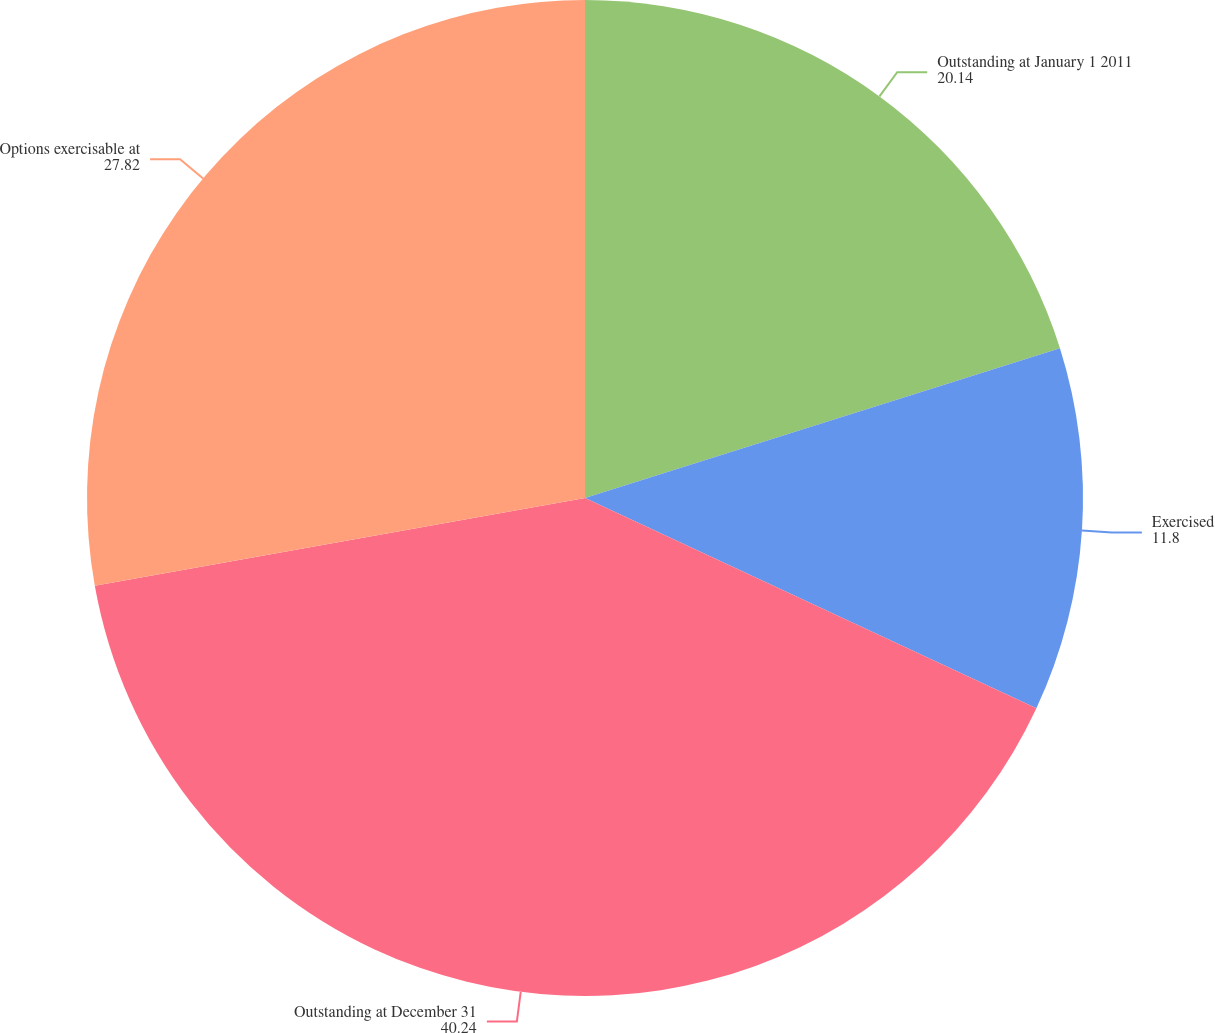Convert chart. <chart><loc_0><loc_0><loc_500><loc_500><pie_chart><fcel>Outstanding at January 1 2011<fcel>Exercised<fcel>Outstanding at December 31<fcel>Options exercisable at<nl><fcel>20.14%<fcel>11.8%<fcel>40.24%<fcel>27.82%<nl></chart> 